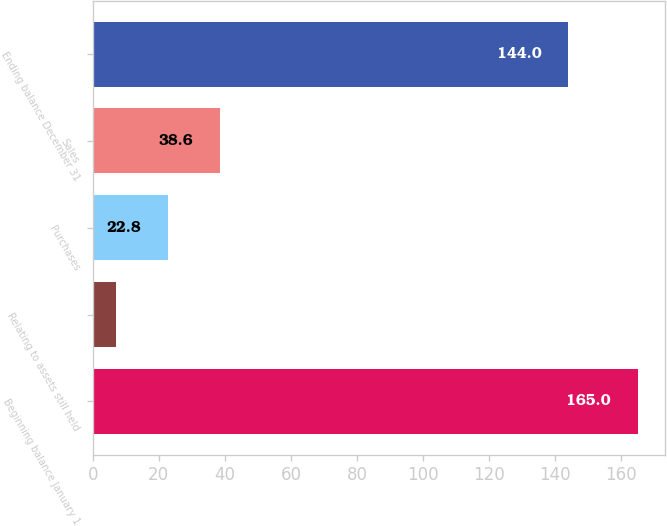Convert chart to OTSL. <chart><loc_0><loc_0><loc_500><loc_500><bar_chart><fcel>Beginning balance January 1<fcel>Relating to assets still held<fcel>Purchases<fcel>Sales<fcel>Ending balance December 31<nl><fcel>165<fcel>7<fcel>22.8<fcel>38.6<fcel>144<nl></chart> 